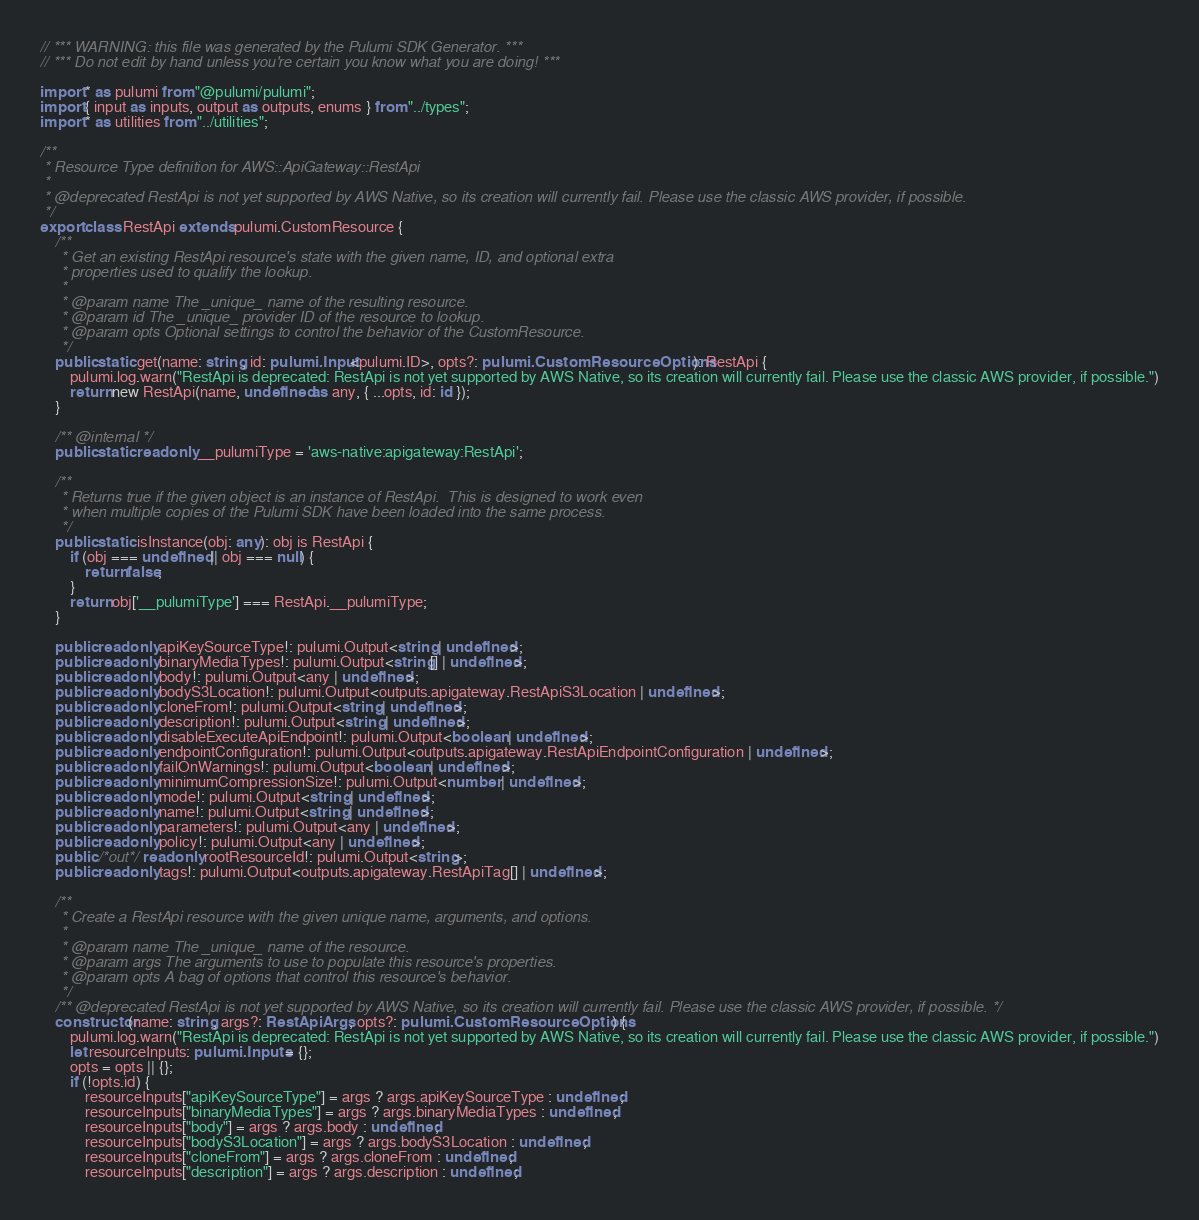Convert code to text. <code><loc_0><loc_0><loc_500><loc_500><_TypeScript_>// *** WARNING: this file was generated by the Pulumi SDK Generator. ***
// *** Do not edit by hand unless you're certain you know what you are doing! ***

import * as pulumi from "@pulumi/pulumi";
import { input as inputs, output as outputs, enums } from "../types";
import * as utilities from "../utilities";

/**
 * Resource Type definition for AWS::ApiGateway::RestApi
 *
 * @deprecated RestApi is not yet supported by AWS Native, so its creation will currently fail. Please use the classic AWS provider, if possible.
 */
export class RestApi extends pulumi.CustomResource {
    /**
     * Get an existing RestApi resource's state with the given name, ID, and optional extra
     * properties used to qualify the lookup.
     *
     * @param name The _unique_ name of the resulting resource.
     * @param id The _unique_ provider ID of the resource to lookup.
     * @param opts Optional settings to control the behavior of the CustomResource.
     */
    public static get(name: string, id: pulumi.Input<pulumi.ID>, opts?: pulumi.CustomResourceOptions): RestApi {
        pulumi.log.warn("RestApi is deprecated: RestApi is not yet supported by AWS Native, so its creation will currently fail. Please use the classic AWS provider, if possible.")
        return new RestApi(name, undefined as any, { ...opts, id: id });
    }

    /** @internal */
    public static readonly __pulumiType = 'aws-native:apigateway:RestApi';

    /**
     * Returns true if the given object is an instance of RestApi.  This is designed to work even
     * when multiple copies of the Pulumi SDK have been loaded into the same process.
     */
    public static isInstance(obj: any): obj is RestApi {
        if (obj === undefined || obj === null) {
            return false;
        }
        return obj['__pulumiType'] === RestApi.__pulumiType;
    }

    public readonly apiKeySourceType!: pulumi.Output<string | undefined>;
    public readonly binaryMediaTypes!: pulumi.Output<string[] | undefined>;
    public readonly body!: pulumi.Output<any | undefined>;
    public readonly bodyS3Location!: pulumi.Output<outputs.apigateway.RestApiS3Location | undefined>;
    public readonly cloneFrom!: pulumi.Output<string | undefined>;
    public readonly description!: pulumi.Output<string | undefined>;
    public readonly disableExecuteApiEndpoint!: pulumi.Output<boolean | undefined>;
    public readonly endpointConfiguration!: pulumi.Output<outputs.apigateway.RestApiEndpointConfiguration | undefined>;
    public readonly failOnWarnings!: pulumi.Output<boolean | undefined>;
    public readonly minimumCompressionSize!: pulumi.Output<number | undefined>;
    public readonly mode!: pulumi.Output<string | undefined>;
    public readonly name!: pulumi.Output<string | undefined>;
    public readonly parameters!: pulumi.Output<any | undefined>;
    public readonly policy!: pulumi.Output<any | undefined>;
    public /*out*/ readonly rootResourceId!: pulumi.Output<string>;
    public readonly tags!: pulumi.Output<outputs.apigateway.RestApiTag[] | undefined>;

    /**
     * Create a RestApi resource with the given unique name, arguments, and options.
     *
     * @param name The _unique_ name of the resource.
     * @param args The arguments to use to populate this resource's properties.
     * @param opts A bag of options that control this resource's behavior.
     */
    /** @deprecated RestApi is not yet supported by AWS Native, so its creation will currently fail. Please use the classic AWS provider, if possible. */
    constructor(name: string, args?: RestApiArgs, opts?: pulumi.CustomResourceOptions) {
        pulumi.log.warn("RestApi is deprecated: RestApi is not yet supported by AWS Native, so its creation will currently fail. Please use the classic AWS provider, if possible.")
        let resourceInputs: pulumi.Inputs = {};
        opts = opts || {};
        if (!opts.id) {
            resourceInputs["apiKeySourceType"] = args ? args.apiKeySourceType : undefined;
            resourceInputs["binaryMediaTypes"] = args ? args.binaryMediaTypes : undefined;
            resourceInputs["body"] = args ? args.body : undefined;
            resourceInputs["bodyS3Location"] = args ? args.bodyS3Location : undefined;
            resourceInputs["cloneFrom"] = args ? args.cloneFrom : undefined;
            resourceInputs["description"] = args ? args.description : undefined;</code> 